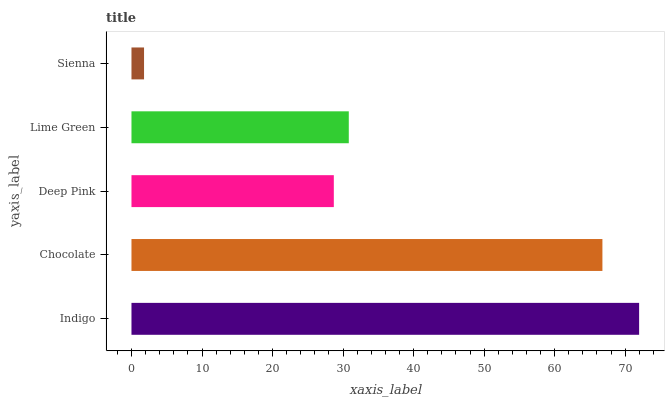Is Sienna the minimum?
Answer yes or no. Yes. Is Indigo the maximum?
Answer yes or no. Yes. Is Chocolate the minimum?
Answer yes or no. No. Is Chocolate the maximum?
Answer yes or no. No. Is Indigo greater than Chocolate?
Answer yes or no. Yes. Is Chocolate less than Indigo?
Answer yes or no. Yes. Is Chocolate greater than Indigo?
Answer yes or no. No. Is Indigo less than Chocolate?
Answer yes or no. No. Is Lime Green the high median?
Answer yes or no. Yes. Is Lime Green the low median?
Answer yes or no. Yes. Is Chocolate the high median?
Answer yes or no. No. Is Deep Pink the low median?
Answer yes or no. No. 